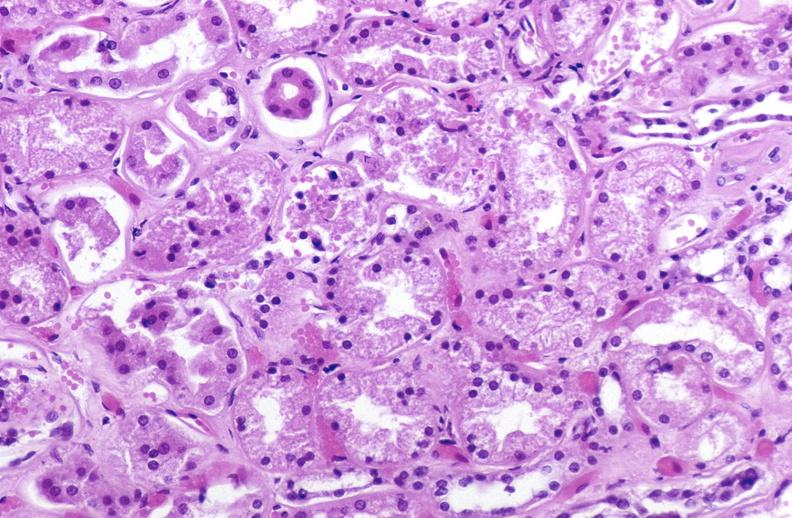s case of peritonitis slide present?
Answer the question using a single word or phrase. No 